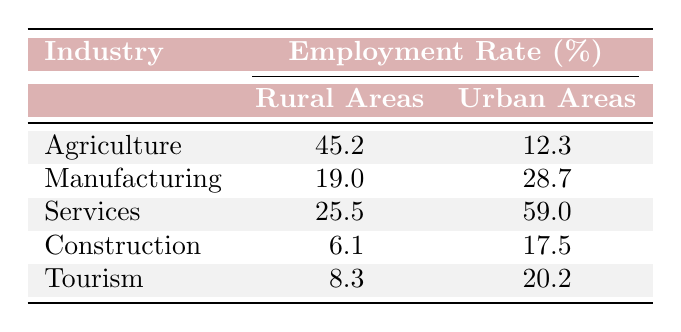What is the employment rate in rural areas for the Agriculture industry? The table shows under the "Agriculture" row that the employment rate in rural areas is listed as 45.2%.
Answer: 45.2% Which industry has the highest employment rate in urban areas? By comparing the urban area employment rates in the table, "Services" has the highest rate listed at 59.0%.
Answer: Services What is the difference in employment rates between the Manufacturing industry in urban and rural areas? The employment rate for Manufacturing in rural areas is 19.0% and in urban areas is 28.7%. The difference is calculated as 28.7% - 19.0% = 9.7%.
Answer: 9.7% Is the employment rate for Construction higher in rural areas than in urban areas? The employment rates for Construction are 6.1% in rural areas and 17.5% in urban areas. Since 6.1% is less than 17.5%, the answer is No.
Answer: No What is the average employment rate for the Services industry in both urban and rural areas? The employment rate for Services is 25.5% in rural areas and 59.0% in urban areas. The average is calculated as (25.5% + 59.0%) / 2 = 42.25%.
Answer: 42.25% Does the Agriculture industry have a higher employment rate in rural areas than the Tourism industry in urban areas? The Agricultural employment rate in rural areas is 45.2%, while the Tourism employment rate in urban areas is 20.2%. Since 45.2% is greater than 20.2%, the answer is Yes.
Answer: Yes What is the total employment rate for all industries in rural areas combined? The total employment rate for rural areas combines the rates: 45.2% (Agriculture) + 19.0% (Manufacturing) + 25.5% (Services) + 6.1% (Construction) + 8.3% (Tourism) = 104.1%.
Answer: 104.1% Which location has a lower average employment rate across all industries: rural areas or urban areas? To find the average for rural areas: (45.2 + 19.0 + 25.5 + 6.1 + 8.3) / 5 = 20.2%. For urban areas: (12.3 + 28.7 + 59.0 + 17.5 + 20.2) / 5 = 19.54%. Since 20.2% (rural) is greater than 19.54% (urban), rural areas have a higher average. Therefore, urban areas have a lower average.
Answer: Urban areas Which industry has the lowest employment rate in rural areas and what is that rate? The table shows that "Construction" has the lowest employment rate in rural areas at 6.1%.
Answer: Construction, 6.1% 